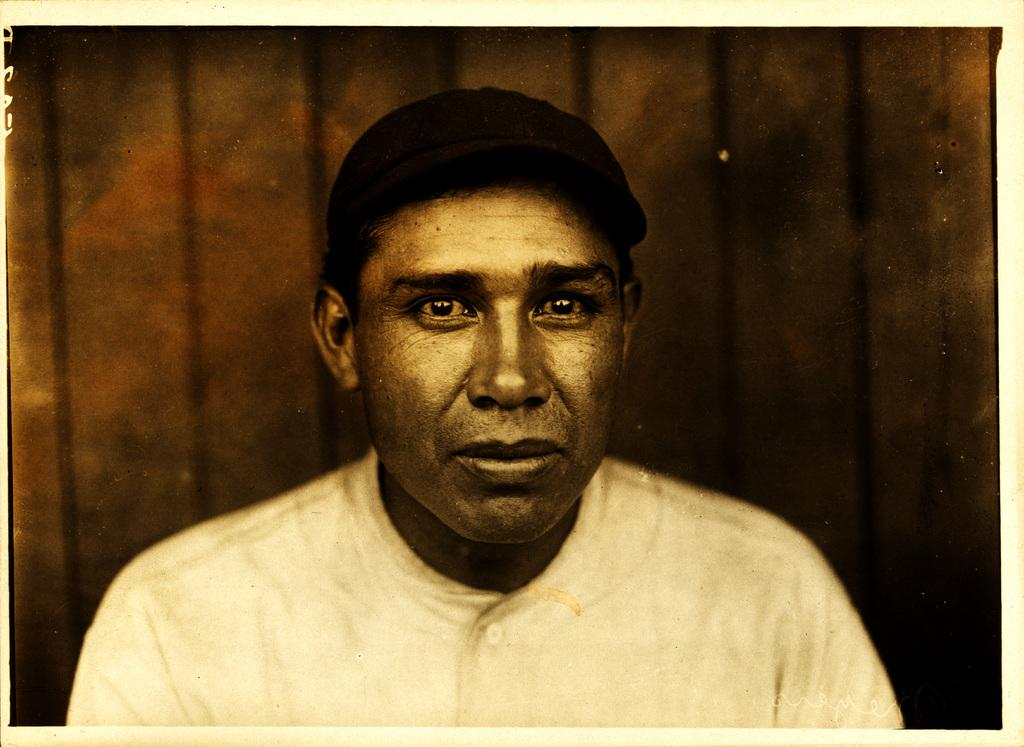Who is present in the image? There is a man in the image. What can be seen in the background of the image? There is a wooden wall in the background of the image. What type of silverware is being used by the man in the image? There is no silverware present in the image; the man is not using any utensils. 